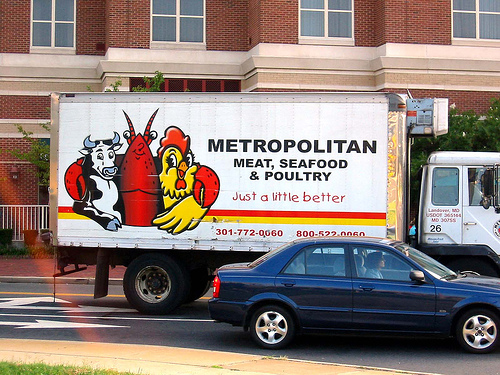<image>
Is there a food truck behind the car? Yes. From this viewpoint, the food truck is positioned behind the car, with the car partially or fully occluding the food truck. Is there a cow behind the lobster? No. The cow is not behind the lobster. From this viewpoint, the cow appears to be positioned elsewhere in the scene. Is there a chicken to the right of the shrimp? Yes. From this viewpoint, the chicken is positioned to the right side relative to the shrimp. 